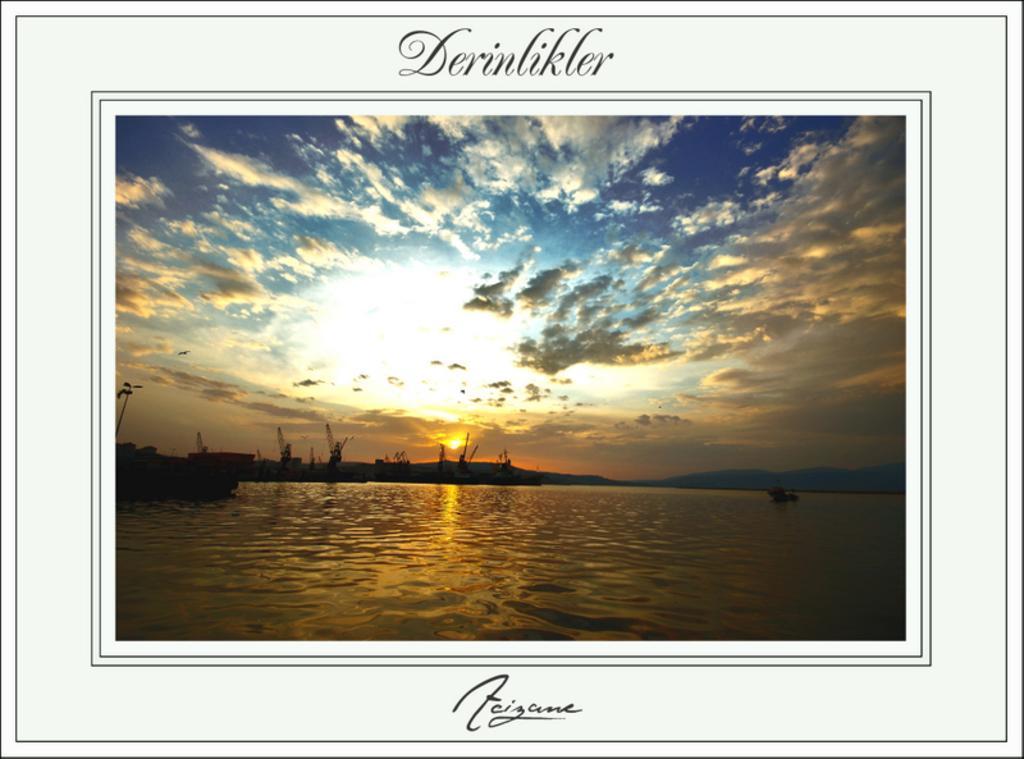Please provide a concise description of this image. This image consists of a frame in which there is water along with boats. At the top, there are clouds in the sky. And there is a sun in the middle. 